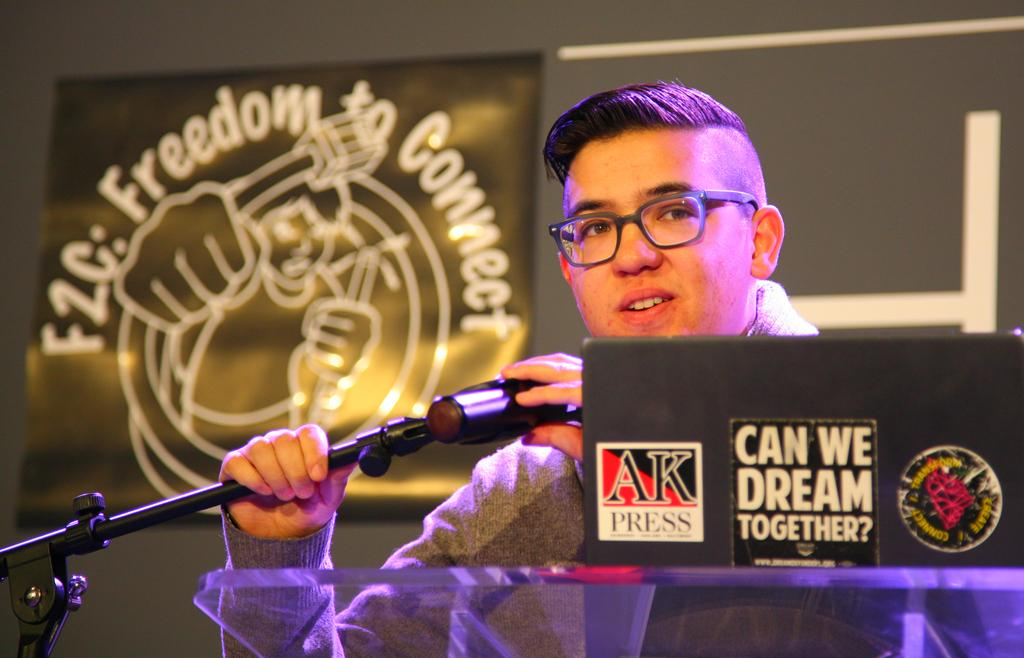What is the person in the image doing? The person is holding a microphone. What object is in front of the person? There is a podium in front of the person. What device is on the podium? There is a laptop on the podium. What can be seen in the background of the image? There is a board and a wall in the background of the image. What type of table is being exchanged between the bricks in the image? There is no table or bricks present in the image. 